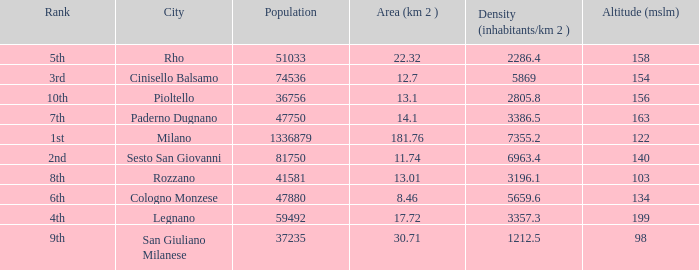Which Altitude (mslm) is the highest one that has a City of legnano, and a Population larger than 59492? None. 